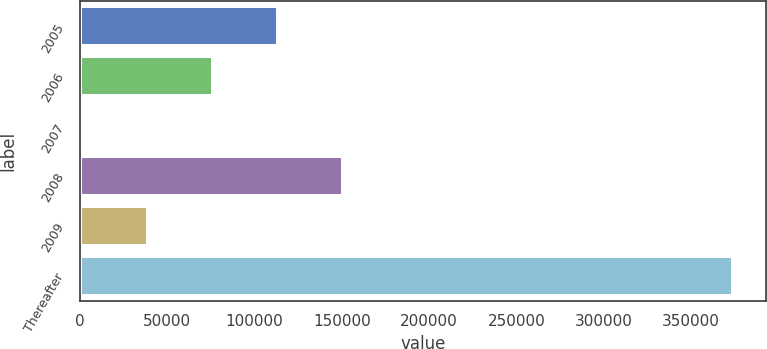<chart> <loc_0><loc_0><loc_500><loc_500><bar_chart><fcel>2005<fcel>2006<fcel>2007<fcel>2008<fcel>2009<fcel>Thereafter<nl><fcel>113376<fcel>76145.8<fcel>1686<fcel>150606<fcel>38915.9<fcel>373985<nl></chart> 